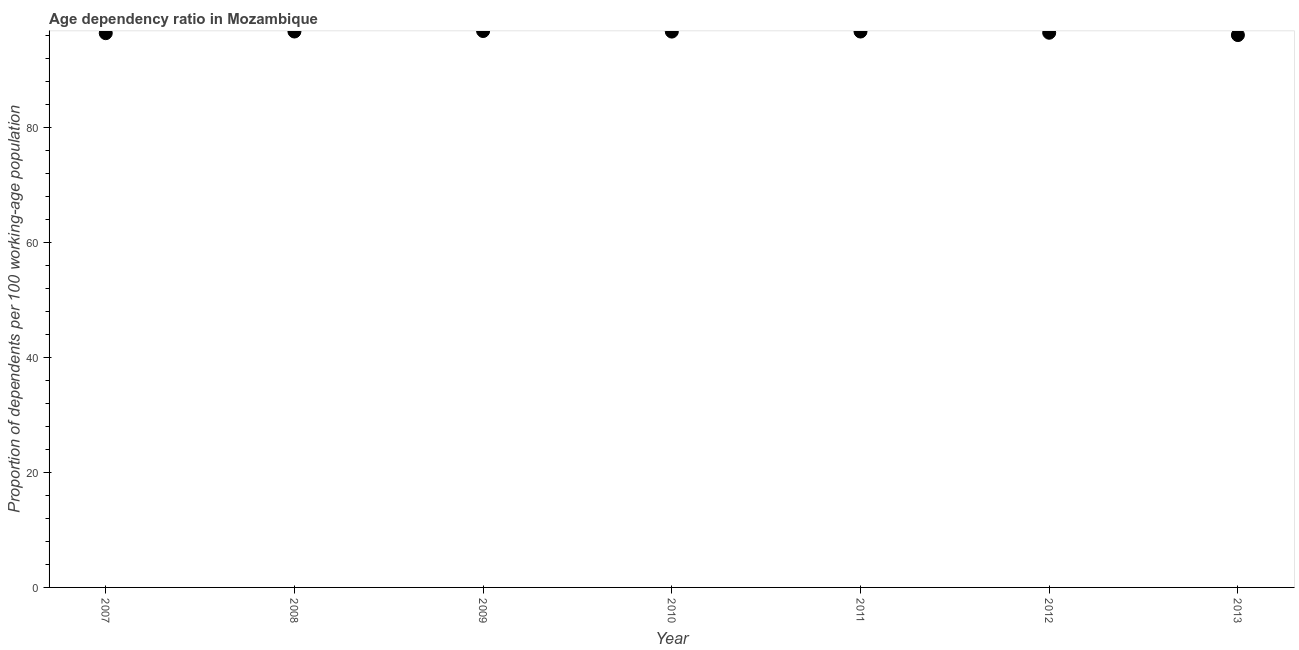What is the age dependency ratio in 2011?
Ensure brevity in your answer.  96.72. Across all years, what is the maximum age dependency ratio?
Provide a succinct answer. 96.81. Across all years, what is the minimum age dependency ratio?
Your response must be concise. 96.11. In which year was the age dependency ratio maximum?
Offer a terse response. 2009. What is the sum of the age dependency ratio?
Give a very brief answer. 676.03. What is the difference between the age dependency ratio in 2012 and 2013?
Provide a short and direct response. 0.41. What is the average age dependency ratio per year?
Offer a terse response. 96.58. What is the median age dependency ratio?
Keep it short and to the point. 96.71. Do a majority of the years between 2009 and 2007 (inclusive) have age dependency ratio greater than 44 ?
Offer a terse response. No. What is the ratio of the age dependency ratio in 2008 to that in 2012?
Your response must be concise. 1. Is the age dependency ratio in 2008 less than that in 2009?
Offer a very short reply. Yes. What is the difference between the highest and the second highest age dependency ratio?
Your response must be concise. 0.09. Is the sum of the age dependency ratio in 2008 and 2013 greater than the maximum age dependency ratio across all years?
Make the answer very short. Yes. What is the difference between the highest and the lowest age dependency ratio?
Give a very brief answer. 0.7. How many dotlines are there?
Keep it short and to the point. 1. How many years are there in the graph?
Give a very brief answer. 7. Are the values on the major ticks of Y-axis written in scientific E-notation?
Offer a terse response. No. Does the graph contain any zero values?
Ensure brevity in your answer.  No. What is the title of the graph?
Provide a succinct answer. Age dependency ratio in Mozambique. What is the label or title of the Y-axis?
Make the answer very short. Proportion of dependents per 100 working-age population. What is the Proportion of dependents per 100 working-age population in 2007?
Provide a short and direct response. 96.44. What is the Proportion of dependents per 100 working-age population in 2008?
Offer a terse response. 96.73. What is the Proportion of dependents per 100 working-age population in 2009?
Keep it short and to the point. 96.81. What is the Proportion of dependents per 100 working-age population in 2010?
Make the answer very short. 96.71. What is the Proportion of dependents per 100 working-age population in 2011?
Offer a terse response. 96.72. What is the Proportion of dependents per 100 working-age population in 2012?
Your answer should be compact. 96.51. What is the Proportion of dependents per 100 working-age population in 2013?
Offer a terse response. 96.11. What is the difference between the Proportion of dependents per 100 working-age population in 2007 and 2008?
Your answer should be compact. -0.29. What is the difference between the Proportion of dependents per 100 working-age population in 2007 and 2009?
Provide a short and direct response. -0.38. What is the difference between the Proportion of dependents per 100 working-age population in 2007 and 2010?
Provide a short and direct response. -0.28. What is the difference between the Proportion of dependents per 100 working-age population in 2007 and 2011?
Provide a succinct answer. -0.29. What is the difference between the Proportion of dependents per 100 working-age population in 2007 and 2012?
Make the answer very short. -0.08. What is the difference between the Proportion of dependents per 100 working-age population in 2007 and 2013?
Ensure brevity in your answer.  0.33. What is the difference between the Proportion of dependents per 100 working-age population in 2008 and 2009?
Give a very brief answer. -0.09. What is the difference between the Proportion of dependents per 100 working-age population in 2008 and 2010?
Ensure brevity in your answer.  0.01. What is the difference between the Proportion of dependents per 100 working-age population in 2008 and 2011?
Offer a very short reply. 0. What is the difference between the Proportion of dependents per 100 working-age population in 2008 and 2012?
Provide a succinct answer. 0.21. What is the difference between the Proportion of dependents per 100 working-age population in 2008 and 2013?
Provide a short and direct response. 0.62. What is the difference between the Proportion of dependents per 100 working-age population in 2009 and 2010?
Give a very brief answer. 0.1. What is the difference between the Proportion of dependents per 100 working-age population in 2009 and 2011?
Ensure brevity in your answer.  0.09. What is the difference between the Proportion of dependents per 100 working-age population in 2009 and 2012?
Ensure brevity in your answer.  0.3. What is the difference between the Proportion of dependents per 100 working-age population in 2009 and 2013?
Provide a succinct answer. 0.7. What is the difference between the Proportion of dependents per 100 working-age population in 2010 and 2011?
Give a very brief answer. -0.01. What is the difference between the Proportion of dependents per 100 working-age population in 2010 and 2012?
Your answer should be very brief. 0.2. What is the difference between the Proportion of dependents per 100 working-age population in 2010 and 2013?
Your answer should be very brief. 0.61. What is the difference between the Proportion of dependents per 100 working-age population in 2011 and 2012?
Your response must be concise. 0.21. What is the difference between the Proportion of dependents per 100 working-age population in 2011 and 2013?
Ensure brevity in your answer.  0.61. What is the difference between the Proportion of dependents per 100 working-age population in 2012 and 2013?
Keep it short and to the point. 0.41. What is the ratio of the Proportion of dependents per 100 working-age population in 2007 to that in 2008?
Your answer should be compact. 1. What is the ratio of the Proportion of dependents per 100 working-age population in 2007 to that in 2009?
Give a very brief answer. 1. What is the ratio of the Proportion of dependents per 100 working-age population in 2007 to that in 2011?
Offer a terse response. 1. What is the ratio of the Proportion of dependents per 100 working-age population in 2007 to that in 2012?
Your answer should be very brief. 1. What is the ratio of the Proportion of dependents per 100 working-age population in 2007 to that in 2013?
Provide a short and direct response. 1. What is the ratio of the Proportion of dependents per 100 working-age population in 2008 to that in 2009?
Offer a terse response. 1. What is the ratio of the Proportion of dependents per 100 working-age population in 2008 to that in 2010?
Your answer should be compact. 1. What is the ratio of the Proportion of dependents per 100 working-age population in 2008 to that in 2011?
Your answer should be compact. 1. What is the ratio of the Proportion of dependents per 100 working-age population in 2008 to that in 2013?
Your answer should be compact. 1.01. What is the ratio of the Proportion of dependents per 100 working-age population in 2009 to that in 2011?
Give a very brief answer. 1. What is the ratio of the Proportion of dependents per 100 working-age population in 2009 to that in 2012?
Offer a terse response. 1. What is the ratio of the Proportion of dependents per 100 working-age population in 2010 to that in 2012?
Provide a succinct answer. 1. What is the ratio of the Proportion of dependents per 100 working-age population in 2011 to that in 2013?
Your answer should be very brief. 1.01. What is the ratio of the Proportion of dependents per 100 working-age population in 2012 to that in 2013?
Provide a succinct answer. 1. 